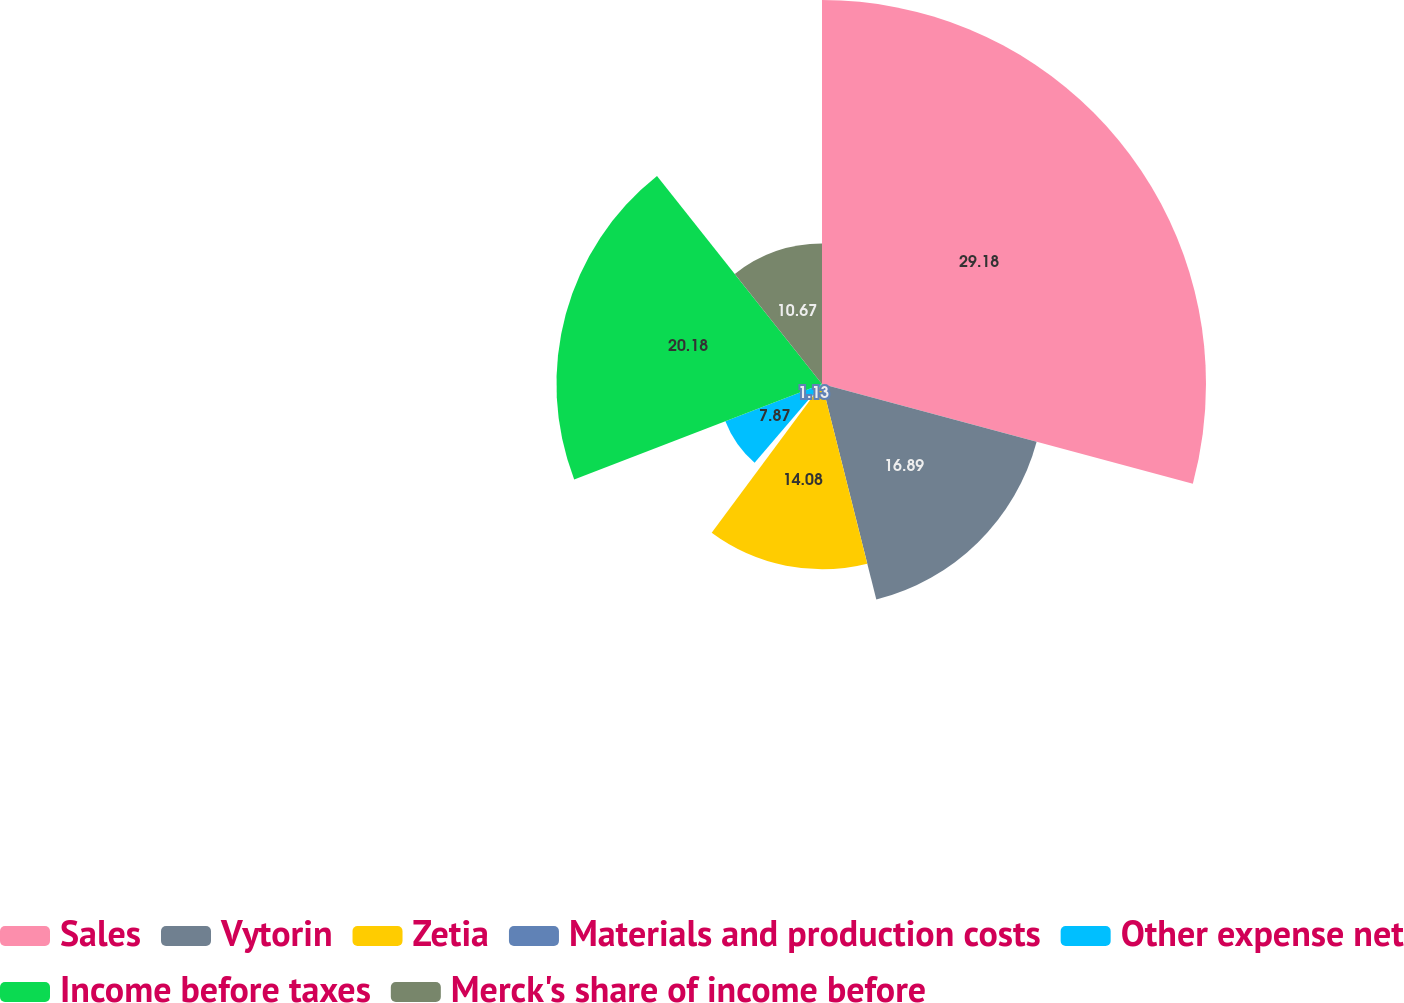Convert chart to OTSL. <chart><loc_0><loc_0><loc_500><loc_500><pie_chart><fcel>Sales<fcel>Vytorin<fcel>Zetia<fcel>Materials and production costs<fcel>Other expense net<fcel>Income before taxes<fcel>Merck's share of income before<nl><fcel>29.18%<fcel>16.89%<fcel>14.08%<fcel>1.13%<fcel>7.87%<fcel>20.18%<fcel>10.67%<nl></chart> 